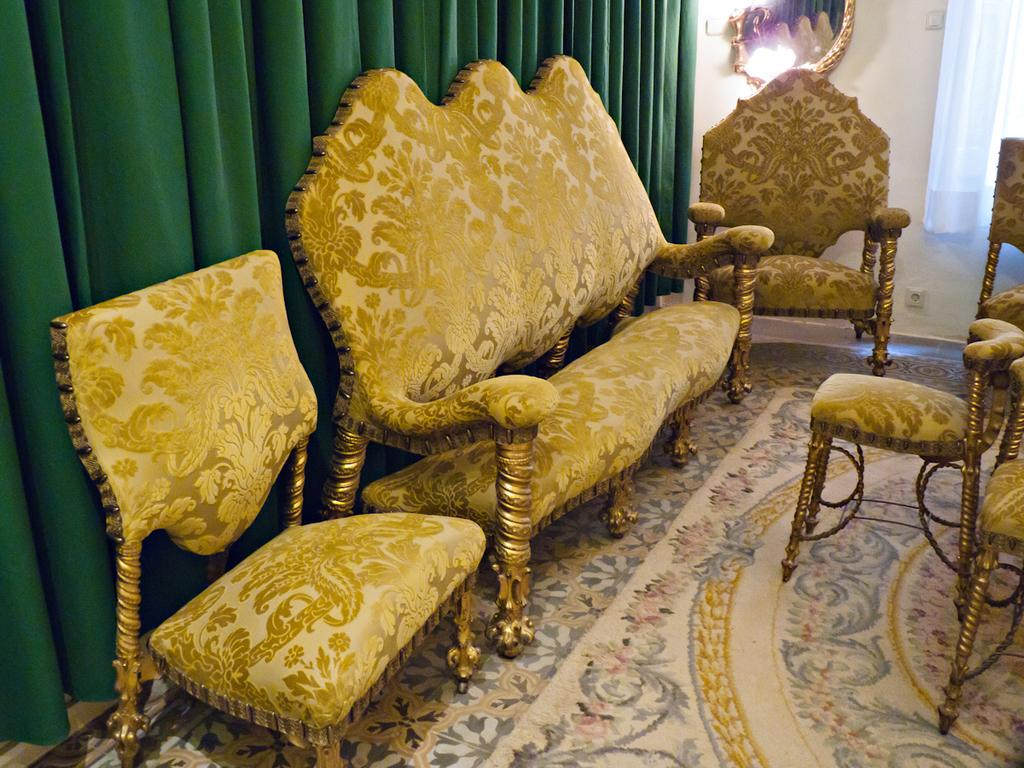What type of furniture is present in the image? There is a sofa and a chair in the image. What can be seen in the background of the image? There are curtains, a mirror, and a wall in the background of the image. What is on the floor in the image? There is a carpet on the floor in the image. What type of stone is used to build the wall in the image? There is no mention of stone being used to build the wall in the wall in the image. The wall is simply described as being present in the background. 